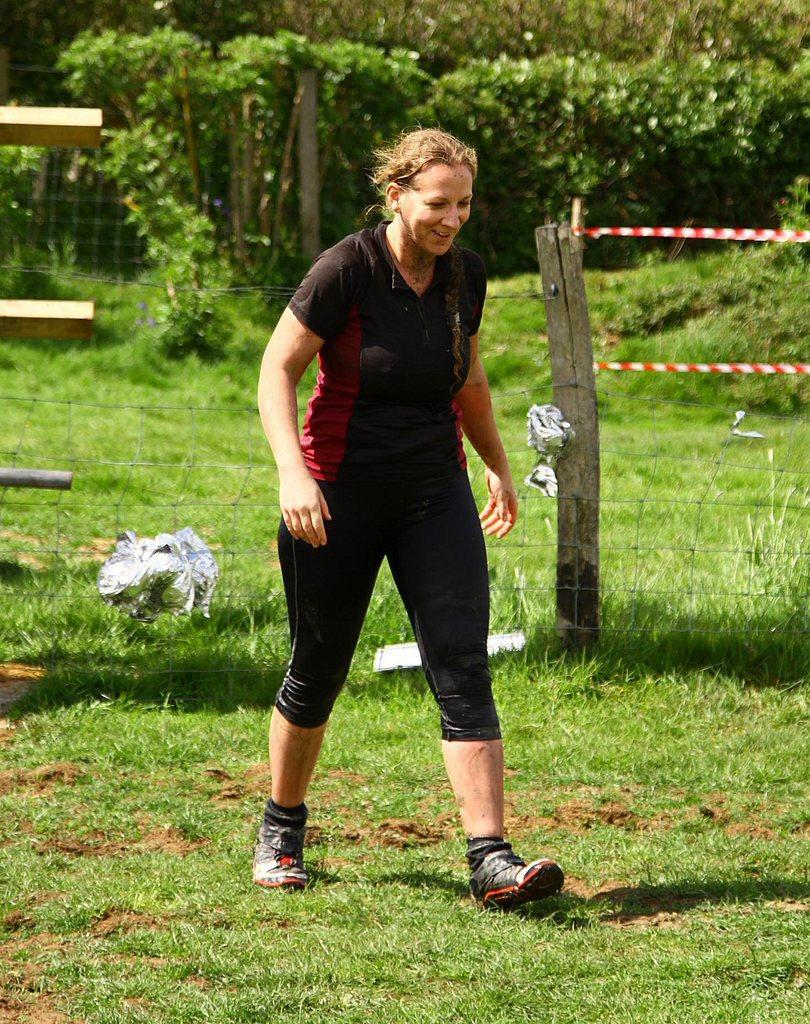In one or two sentences, can you explain what this image depicts? In the center of the image there is a woman walking. At the bottom of the image there is grass. In the background of the image there are trees. There is a fencing. 